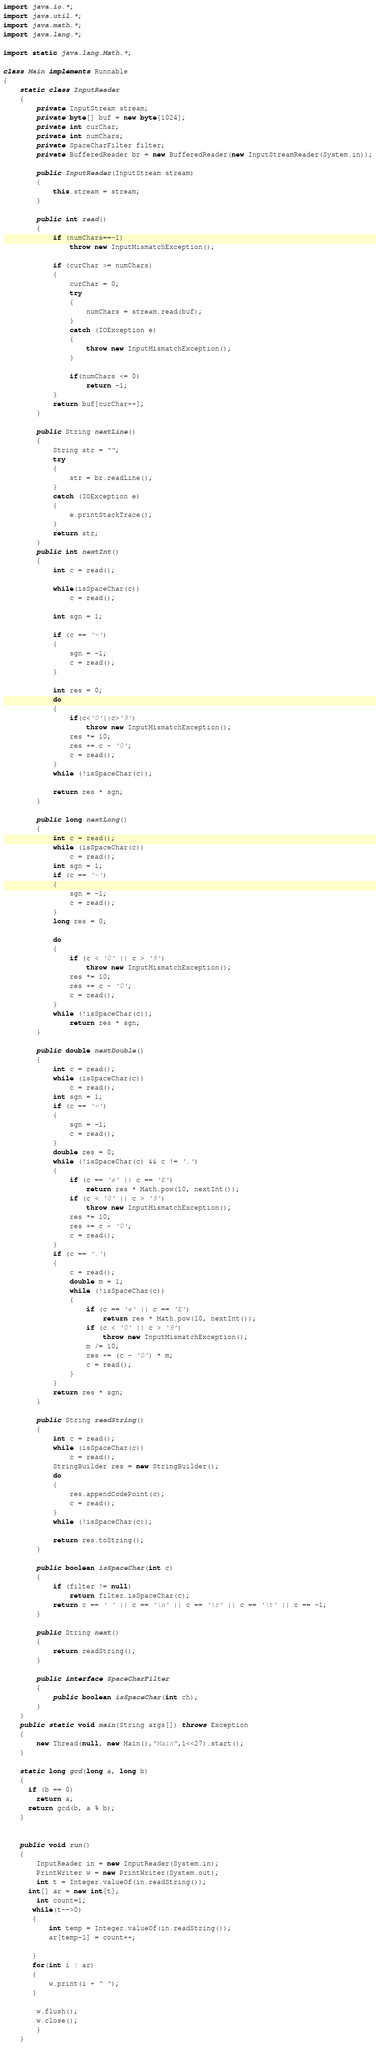Convert code to text. <code><loc_0><loc_0><loc_500><loc_500><_Java_>import java.io.*;
import java.util.*;
import java.math.*;
import java.lang.*;
 
import static java.lang.Math.*;

class Main implements Runnable 
{
    static class InputReader 
    {
        private InputStream stream;
        private byte[] buf = new byte[1024];
        private int curChar;
        private int numChars;
        private SpaceCharFilter filter;
        private BufferedReader br = new BufferedReader(new InputStreamReader(System.in));

        public InputReader(InputStream stream) 
        {
            this.stream = stream;
        }
        
        public int read()
        {
            if (numChars==-1) 
                throw new InputMismatchException();
            
            if (curChar >= numChars) 
            {
                curChar = 0;
                try
                {
                    numChars = stream.read(buf);
                }
                catch (IOException e)
                {
                    throw new InputMismatchException();
                }
                
                if(numChars <= 0)               
                    return -1;
            }
            return buf[curChar++];
        }
     
        public String nextLine()
        {
            String str = "";
            try
            {
                str = br.readLine();
            }
            catch (IOException e)
            {
                e.printStackTrace();
            }    
            return str;
        }
        public int nextInt() 
        {
            int c = read();
            
            while(isSpaceChar(c)) 
                c = read();
        
            int sgn = 1;
        
            if (c == '-') 
            {
                sgn = -1;
                c = read();
            }
            
            int res = 0;
            do
            {
                if(c<'0'||c>'9') 
                    throw new InputMismatchException();
                res *= 10;
                res += c - '0';
                c = read();
            }
            while (!isSpaceChar(c)); 
        
            return res * sgn;
        }
        
        public long nextLong() 
        {
            int c = read();
            while (isSpaceChar(c))
                c = read();
            int sgn = 1;
            if (c == '-')
            {
                sgn = -1;
                c = read();
            }
            long res = 0;
            
            do 
            {
                if (c < '0' || c > '9')
                    throw new InputMismatchException();
                res *= 10;
                res += c - '0';
                c = read();
            }    
            while (!isSpaceChar(c));
                return res * sgn;
        }
        
        public double nextDouble() 
        {
            int c = read();
            while (isSpaceChar(c))
                c = read();
            int sgn = 1;
            if (c == '-')
            {
                sgn = -1;
                c = read();
            }
            double res = 0;
            while (!isSpaceChar(c) && c != '.') 
            {
                if (c == 'e' || c == 'E')
                    return res * Math.pow(10, nextInt());
                if (c < '0' || c > '9')
                    throw new InputMismatchException();
                res *= 10;
                res += c - '0';
                c = read();
            }
            if (c == '.') 
            {
                c = read();
                double m = 1;
                while (!isSpaceChar(c))
                {
                    if (c == 'e' || c == 'E')
                        return res * Math.pow(10, nextInt());
                    if (c < '0' || c > '9')
                        throw new InputMismatchException();
                    m /= 10;
                    res += (c - '0') * m;
                    c = read();
                }
            }
            return res * sgn;
        }
    
        public String readString() 
        {
            int c = read();
            while (isSpaceChar(c))
                c = read();
            StringBuilder res = new StringBuilder();
            do 
            {
                res.appendCodePoint(c);
                c = read();
            } 
            while (!isSpaceChar(c));
            
            return res.toString();
        }
     
        public boolean isSpaceChar(int c) 
        {
            if (filter != null)
                return filter.isSpaceChar(c);
            return c == ' ' || c == '\n' || c == '\r' || c == '\t' || c == -1;
        }
     
        public String next()
        {
            return readString();
        }
        
        public interface SpaceCharFilter
        {
            public boolean isSpaceChar(int ch);
        }
    }
    public static void main(String args[]) throws Exception 
    {
        new Thread(null, new Main(),"Main",1<<27).start();
    }
    
    static long gcd(long a, long b) 
    { 
      if (b == 0) 
        return a; 
      return gcd(b, a % b);  
    } 

   
    public void run()
    {
        InputReader in = new InputReader(System.in);
        PrintWriter w = new PrintWriter(System.out);
        int t = Integer.valueOf(in.readString());
      int[] ar = new int[t];
        int count=1;
       while(t-->0)
       {
           int temp = Integer.valueOf(in.readString());
           ar[temp-1] = count++; 
          
       }
       for(int i : ar)
       {
           w.print(i + " ");
       }
        
        w.flush();
        w.close(); 
        }
    }

</code> 